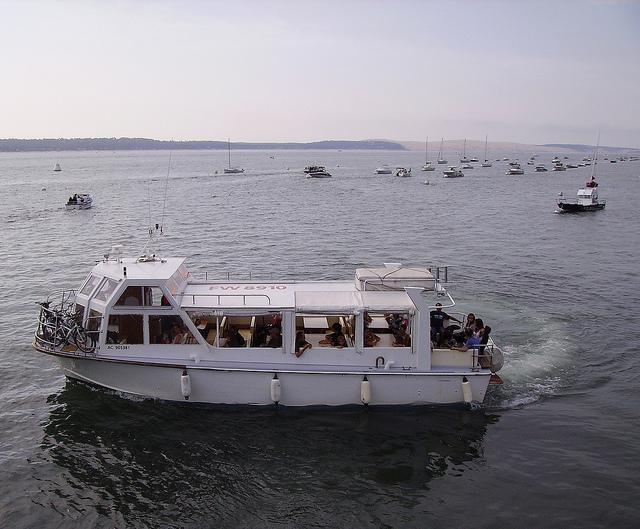How many boats are there?
Give a very brief answer. 2. 